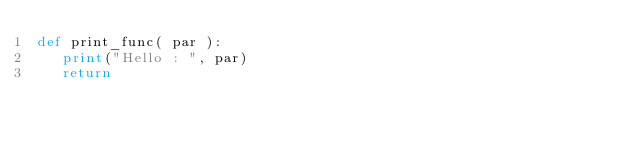<code> <loc_0><loc_0><loc_500><loc_500><_Python_>def print_func( par ):
   print("Hello : ", par)
   return</code> 